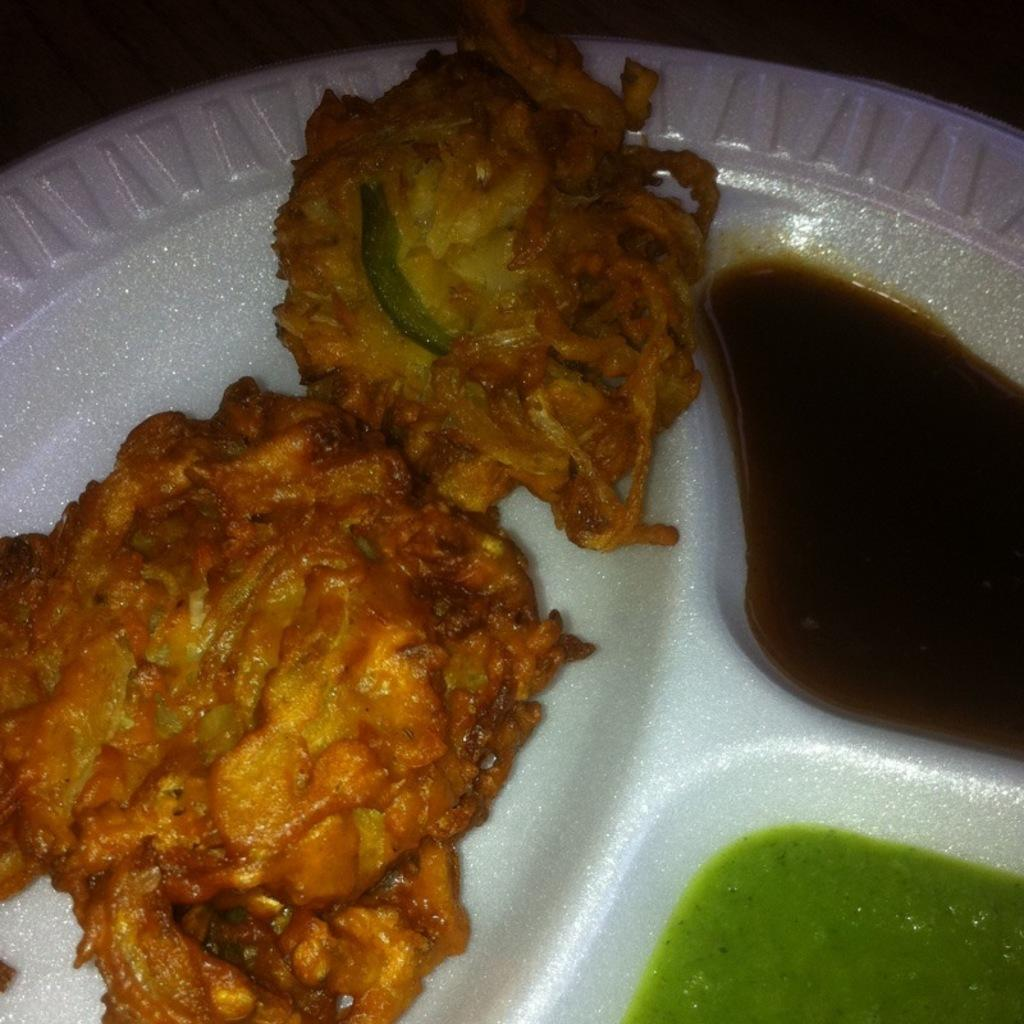What is on the plate that is visible in the image? The plate contains snacks. What accompanies the snacks on the plate? There is sauce on the plate. What grade is the sheet of paper on the plate? There is no sheet of paper on the plate; it contains snacks and sauce. 